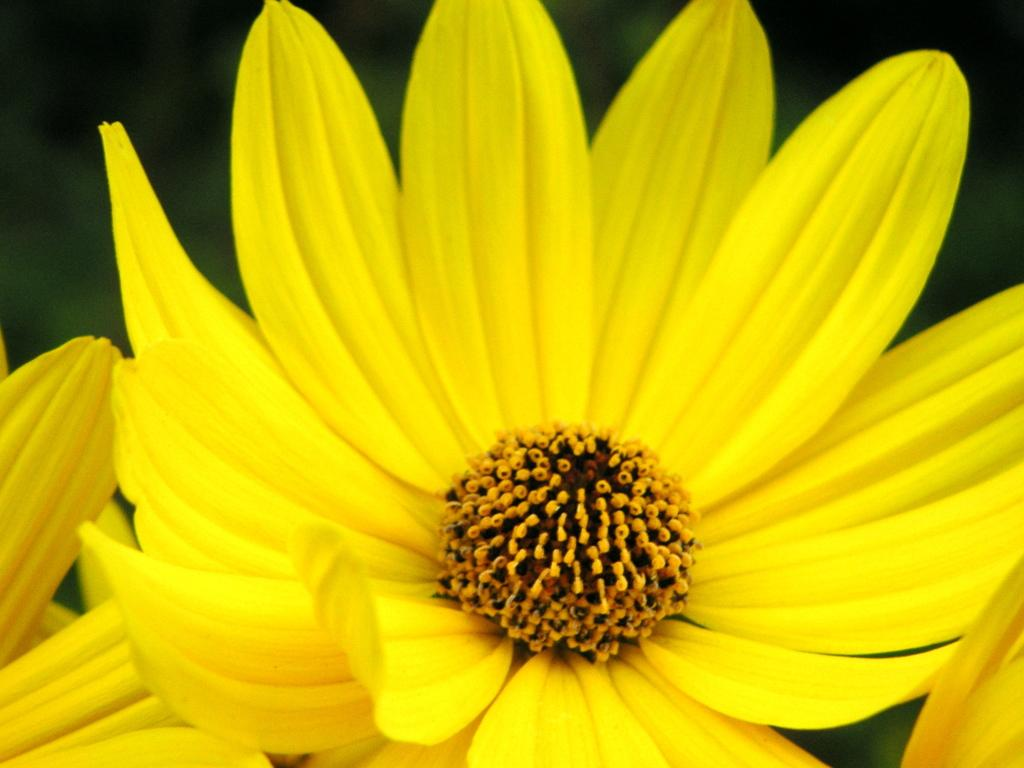What type of flower is present in the image? There is a yellow flower in the image. Where is the flower located in the image? The flower is present over a place. What can be seen in the middle of the flower? Pollen grains are visible in the middle of the flower. What type of notebook is the flower using to take notes in the image? There is no notebook present in the image, and flowers do not have the ability to take notes. 